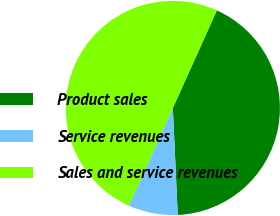<chart> <loc_0><loc_0><loc_500><loc_500><pie_chart><fcel>Product sales<fcel>Service revenues<fcel>Sales and service revenues<nl><fcel>42.53%<fcel>7.47%<fcel>50.0%<nl></chart> 